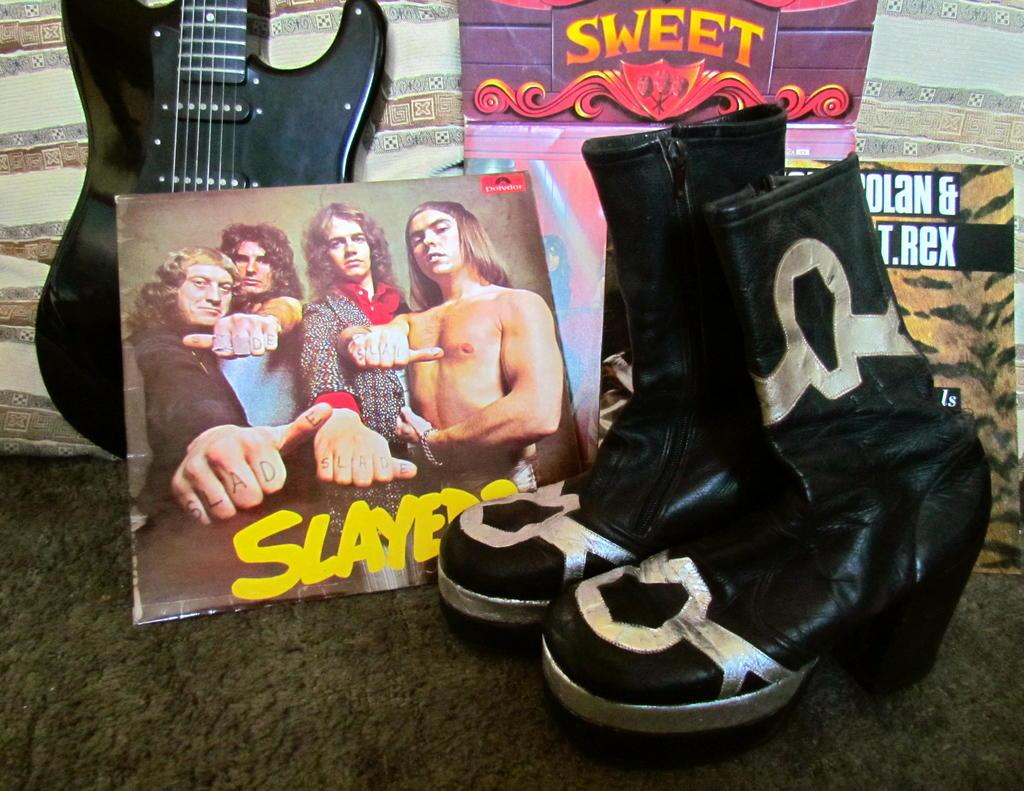What musical instrument is hanging on the wall in the image? There is a guitar on the wall in the image. What object is located beside the guitar on the wall? There is a shoe beside the guitar in the image. Is there any other item between the shoe and the guitar on the wall? Yes, there is a poster between the shoe and the guitar in the image. What type of advice is being given by the crowd in the image? There is no crowd present in the image, so no advice can be given or received. What color is the curtain hanging beside the guitar in the image? There is no curtain present in the image; only a guitar, a shoe, and a poster are visible. 